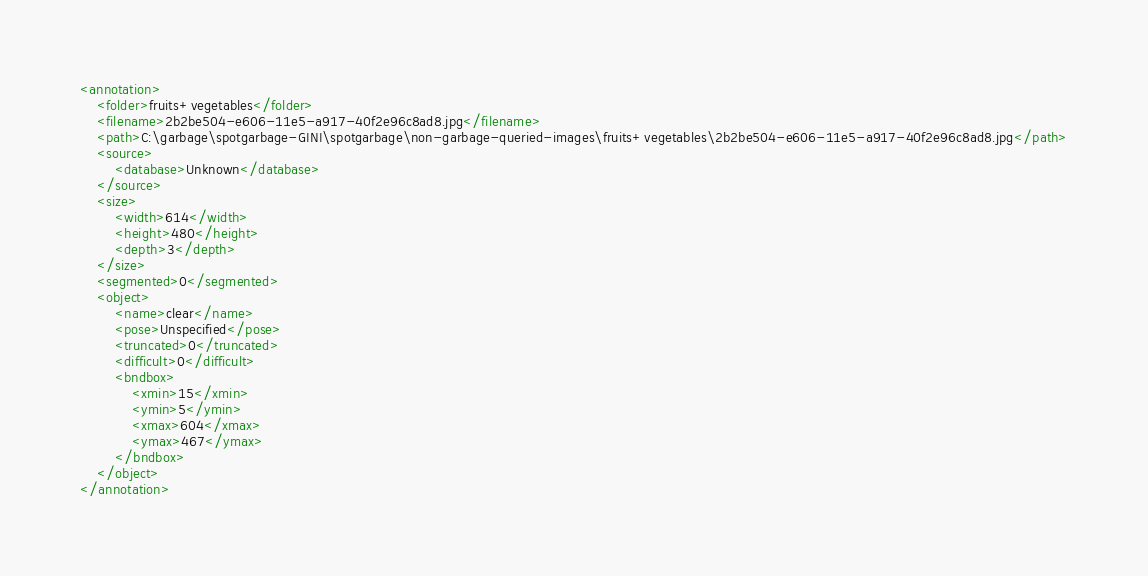<code> <loc_0><loc_0><loc_500><loc_500><_XML_><annotation>
	<folder>fruits+vegetables</folder>
	<filename>2b2be504-e606-11e5-a917-40f2e96c8ad8.jpg</filename>
	<path>C:\garbage\spotgarbage-GINI\spotgarbage\non-garbage-queried-images\fruits+vegetables\2b2be504-e606-11e5-a917-40f2e96c8ad8.jpg</path>
	<source>
		<database>Unknown</database>
	</source>
	<size>
		<width>614</width>
		<height>480</height>
		<depth>3</depth>
	</size>
	<segmented>0</segmented>
	<object>
		<name>clear</name>
		<pose>Unspecified</pose>
		<truncated>0</truncated>
		<difficult>0</difficult>
		<bndbox>
			<xmin>15</xmin>
			<ymin>5</ymin>
			<xmax>604</xmax>
			<ymax>467</ymax>
		</bndbox>
	</object>
</annotation>
</code> 